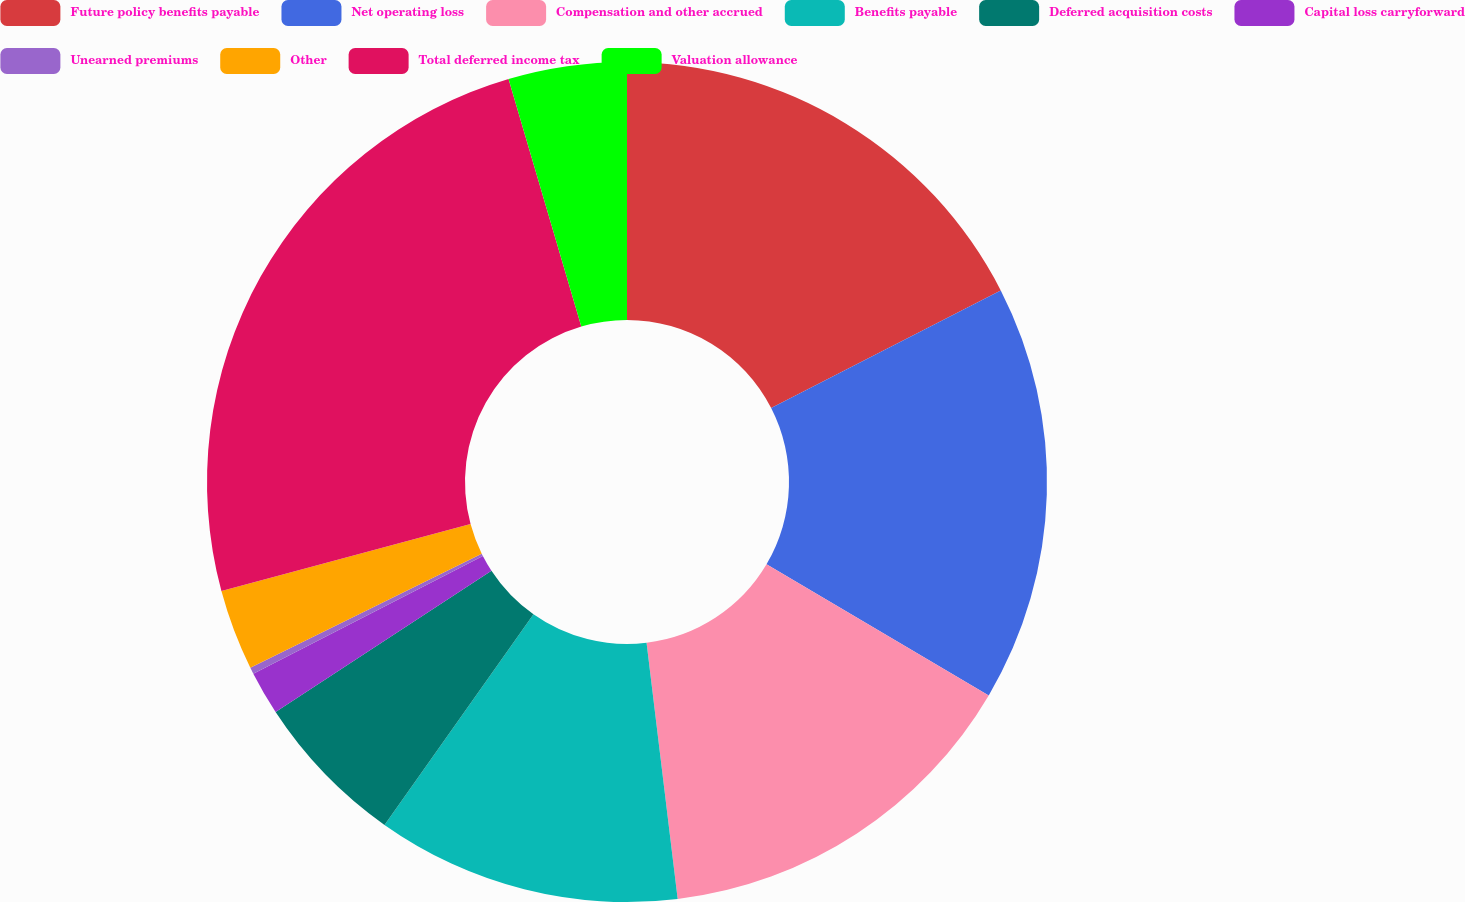Convert chart to OTSL. <chart><loc_0><loc_0><loc_500><loc_500><pie_chart><fcel>Future policy benefits payable<fcel>Net operating loss<fcel>Compensation and other accrued<fcel>Benefits payable<fcel>Deferred acquisition costs<fcel>Capital loss carryforward<fcel>Unearned premiums<fcel>Other<fcel>Total deferred income tax<fcel>Valuation allowance<nl><fcel>17.46%<fcel>16.02%<fcel>14.59%<fcel>11.72%<fcel>5.98%<fcel>1.68%<fcel>0.25%<fcel>3.11%<fcel>24.63%<fcel>4.55%<nl></chart> 